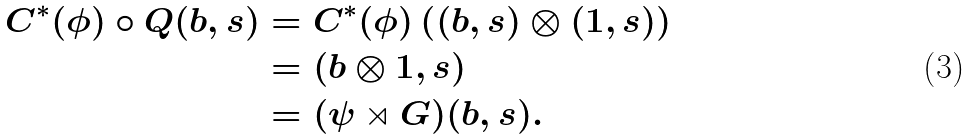<formula> <loc_0><loc_0><loc_500><loc_500>C ^ { * } ( \phi ) \circ Q ( b , s ) & = C ^ { * } ( \phi ) \left ( ( b , s ) \otimes ( 1 , s ) \right ) \\ & = ( b \otimes 1 , s ) \\ & = ( \psi \rtimes G ) ( b , s ) .</formula> 